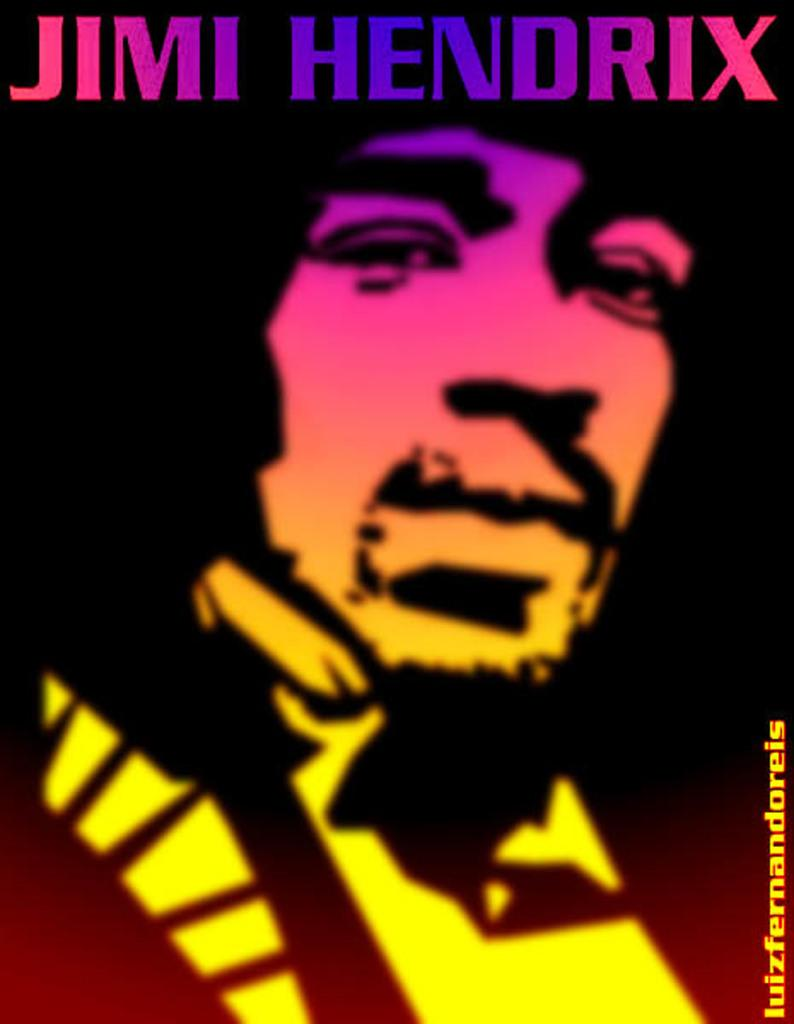What is the main subject of the poster in the image? There is a person in the poster. Where is the text located in the image? The text is on the top and right side of the image. Can you see any pockets on the person in the poster? There is no information about pockets on the person in the image, so we cannot determine if they are present or not. Is the person in the poster at an airport? There is no information about the location or context of the person in the image, so we cannot determine if they are at an airport or not. 